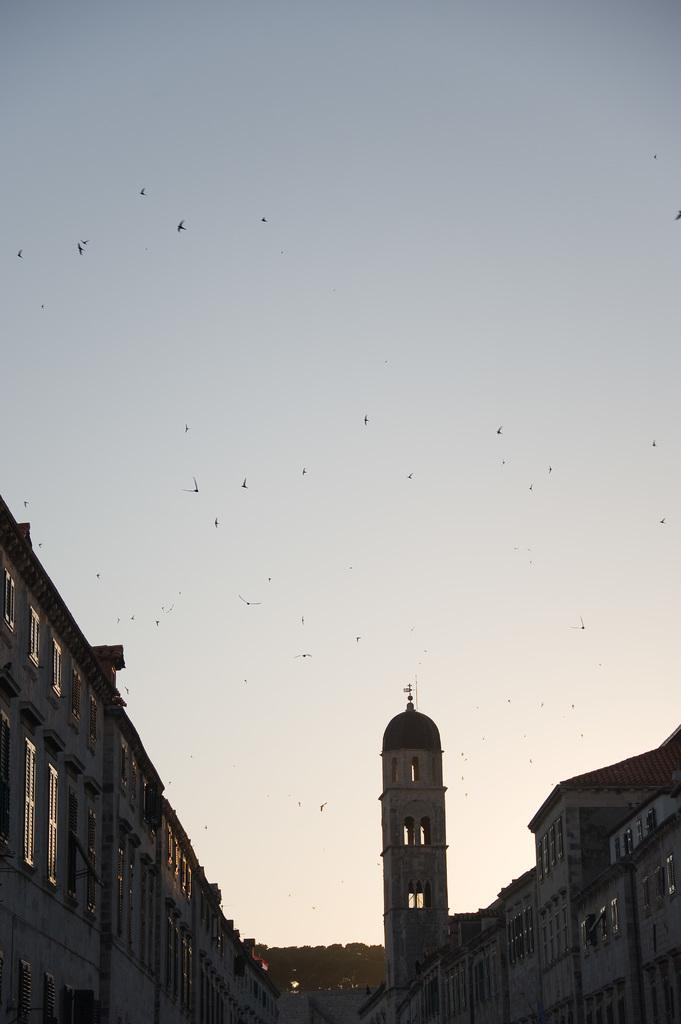What type of structure is present in the image? There is a monument and a tower in the image. What can be seen in the center of the image? There are many birds in the center of the image. What is visible at the top of the image? The sky is visible at the top of the image. How many snakes are crawling on the monument in the image? There are no snakes present in the image; it features a monument, a tower, and many birds. What type of things are covering the ground in the image? The ground is not visible in the image, so it is impossible to determine what, if anything, is covering it. 